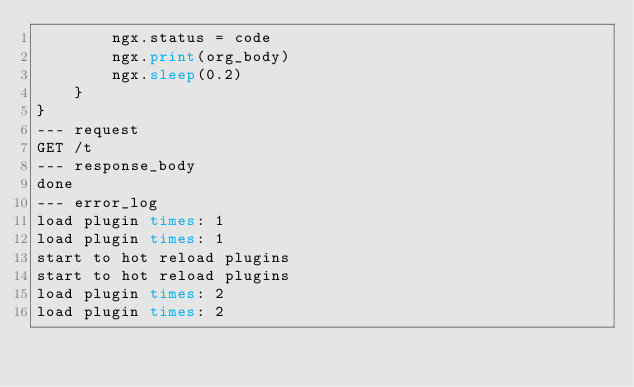Convert code to text. <code><loc_0><loc_0><loc_500><loc_500><_Perl_>        ngx.status = code
        ngx.print(org_body)
        ngx.sleep(0.2)
    }
}
--- request
GET /t
--- response_body
done
--- error_log
load plugin times: 1
load plugin times: 1
start to hot reload plugins
start to hot reload plugins
load plugin times: 2
load plugin times: 2
</code> 